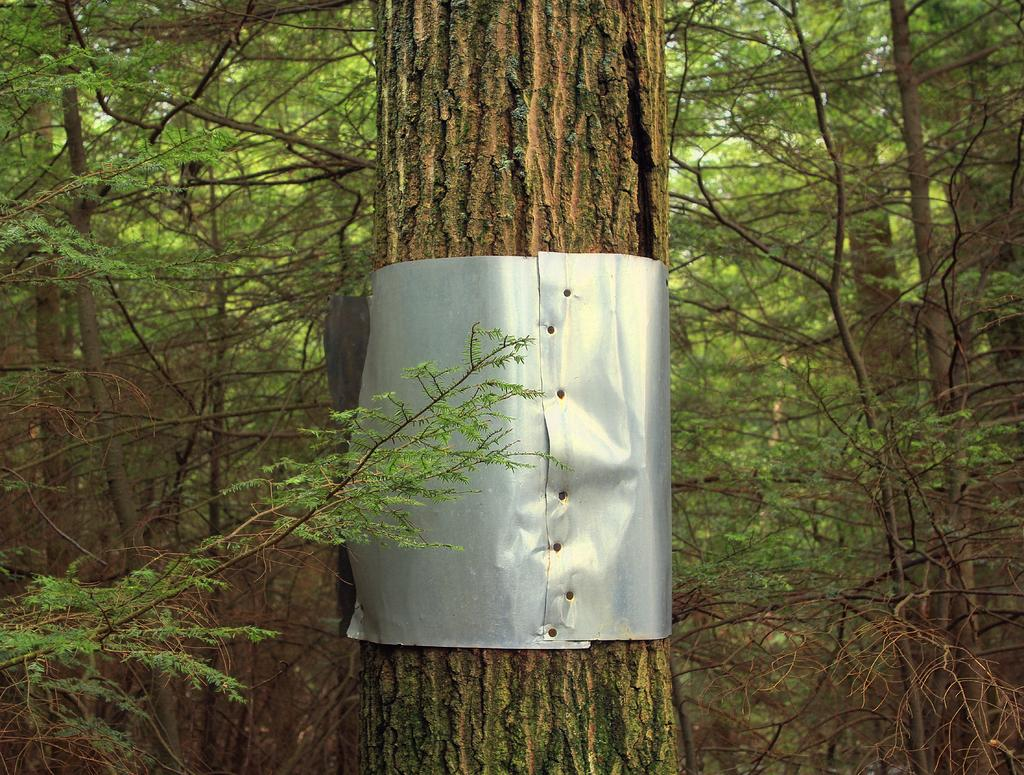What object is present in the image? There is a trunk in the image. What can be seen in the background of the image? There are trees in the background of the image. What is the color of the trees in the image? The trees are green in color. What is visible in the background of the image besides the trees? The sky is visible in the background of the image. What is the color of the sky in the image? The sky is white in color. What type of stitch is used to sew the title onto the sign in the image? There is no sign or title present in the image, so it is not possible to determine what type of stitch might be used. 